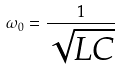<formula> <loc_0><loc_0><loc_500><loc_500>\omega _ { 0 } = \frac { 1 } { \sqrt { L C } }</formula> 